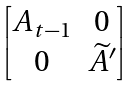Convert formula to latex. <formula><loc_0><loc_0><loc_500><loc_500>\begin{bmatrix} A _ { t - 1 } & 0 \\ 0 & \widetilde { A } ^ { \prime } \end{bmatrix}</formula> 